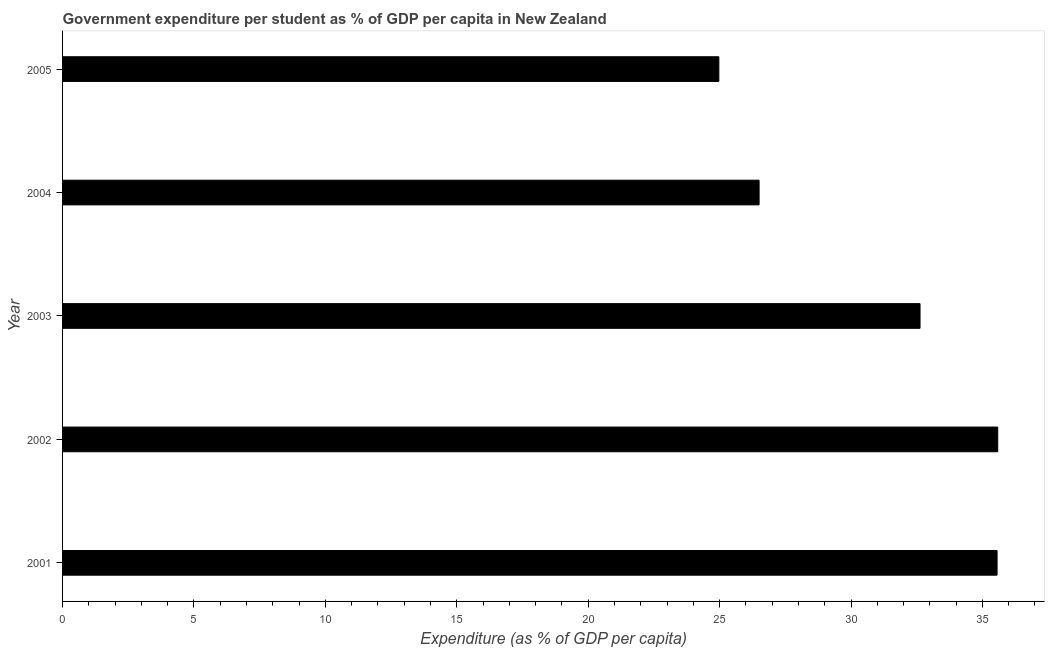Does the graph contain grids?
Provide a succinct answer. No. What is the title of the graph?
Make the answer very short. Government expenditure per student as % of GDP per capita in New Zealand. What is the label or title of the X-axis?
Give a very brief answer. Expenditure (as % of GDP per capita). What is the label or title of the Y-axis?
Provide a short and direct response. Year. What is the government expenditure per student in 2004?
Ensure brevity in your answer.  26.5. Across all years, what is the maximum government expenditure per student?
Provide a short and direct response. 35.58. Across all years, what is the minimum government expenditure per student?
Provide a succinct answer. 24.97. What is the sum of the government expenditure per student?
Offer a very short reply. 155.24. What is the difference between the government expenditure per student in 2001 and 2005?
Your response must be concise. 10.59. What is the average government expenditure per student per year?
Provide a short and direct response. 31.05. What is the median government expenditure per student?
Your response must be concise. 32.63. In how many years, is the government expenditure per student greater than 10 %?
Provide a succinct answer. 5. Do a majority of the years between 2003 and 2001 (inclusive) have government expenditure per student greater than 12 %?
Your response must be concise. Yes. What is the ratio of the government expenditure per student in 2001 to that in 2005?
Your answer should be very brief. 1.42. Is the difference between the government expenditure per student in 2002 and 2003 greater than the difference between any two years?
Your response must be concise. No. What is the difference between the highest and the second highest government expenditure per student?
Give a very brief answer. 0.03. What is the difference between the highest and the lowest government expenditure per student?
Keep it short and to the point. 10.61. How many years are there in the graph?
Offer a terse response. 5. What is the difference between two consecutive major ticks on the X-axis?
Ensure brevity in your answer.  5. What is the Expenditure (as % of GDP per capita) in 2001?
Ensure brevity in your answer.  35.56. What is the Expenditure (as % of GDP per capita) in 2002?
Offer a terse response. 35.58. What is the Expenditure (as % of GDP per capita) of 2003?
Offer a very short reply. 32.63. What is the Expenditure (as % of GDP per capita) of 2004?
Keep it short and to the point. 26.5. What is the Expenditure (as % of GDP per capita) of 2005?
Ensure brevity in your answer.  24.97. What is the difference between the Expenditure (as % of GDP per capita) in 2001 and 2002?
Your response must be concise. -0.03. What is the difference between the Expenditure (as % of GDP per capita) in 2001 and 2003?
Your answer should be compact. 2.93. What is the difference between the Expenditure (as % of GDP per capita) in 2001 and 2004?
Give a very brief answer. 9.06. What is the difference between the Expenditure (as % of GDP per capita) in 2001 and 2005?
Ensure brevity in your answer.  10.59. What is the difference between the Expenditure (as % of GDP per capita) in 2002 and 2003?
Your answer should be compact. 2.96. What is the difference between the Expenditure (as % of GDP per capita) in 2002 and 2004?
Offer a very short reply. 9.08. What is the difference between the Expenditure (as % of GDP per capita) in 2002 and 2005?
Your answer should be compact. 10.61. What is the difference between the Expenditure (as % of GDP per capita) in 2003 and 2004?
Give a very brief answer. 6.12. What is the difference between the Expenditure (as % of GDP per capita) in 2003 and 2005?
Provide a succinct answer. 7.66. What is the difference between the Expenditure (as % of GDP per capita) in 2004 and 2005?
Your answer should be compact. 1.53. What is the ratio of the Expenditure (as % of GDP per capita) in 2001 to that in 2003?
Make the answer very short. 1.09. What is the ratio of the Expenditure (as % of GDP per capita) in 2001 to that in 2004?
Offer a terse response. 1.34. What is the ratio of the Expenditure (as % of GDP per capita) in 2001 to that in 2005?
Keep it short and to the point. 1.42. What is the ratio of the Expenditure (as % of GDP per capita) in 2002 to that in 2003?
Ensure brevity in your answer.  1.09. What is the ratio of the Expenditure (as % of GDP per capita) in 2002 to that in 2004?
Offer a very short reply. 1.34. What is the ratio of the Expenditure (as % of GDP per capita) in 2002 to that in 2005?
Provide a succinct answer. 1.43. What is the ratio of the Expenditure (as % of GDP per capita) in 2003 to that in 2004?
Provide a short and direct response. 1.23. What is the ratio of the Expenditure (as % of GDP per capita) in 2003 to that in 2005?
Offer a terse response. 1.31. What is the ratio of the Expenditure (as % of GDP per capita) in 2004 to that in 2005?
Provide a short and direct response. 1.06. 